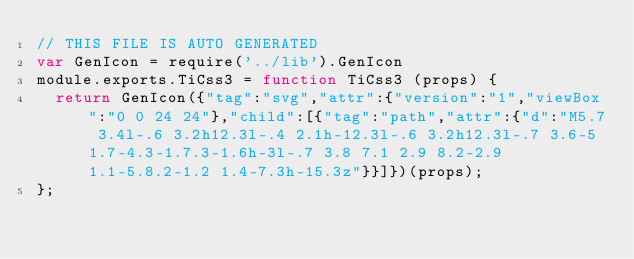Convert code to text. <code><loc_0><loc_0><loc_500><loc_500><_JavaScript_>// THIS FILE IS AUTO GENERATED
var GenIcon = require('../lib').GenIcon
module.exports.TiCss3 = function TiCss3 (props) {
  return GenIcon({"tag":"svg","attr":{"version":"1","viewBox":"0 0 24 24"},"child":[{"tag":"path","attr":{"d":"M5.7 3.4l-.6 3.2h12.3l-.4 2.1h-12.3l-.6 3.2h12.3l-.7 3.6-5 1.7-4.3-1.7.3-1.6h-3l-.7 3.8 7.1 2.9 8.2-2.9 1.1-5.8.2-1.2 1.4-7.3h-15.3z"}}]})(props);
};
</code> 